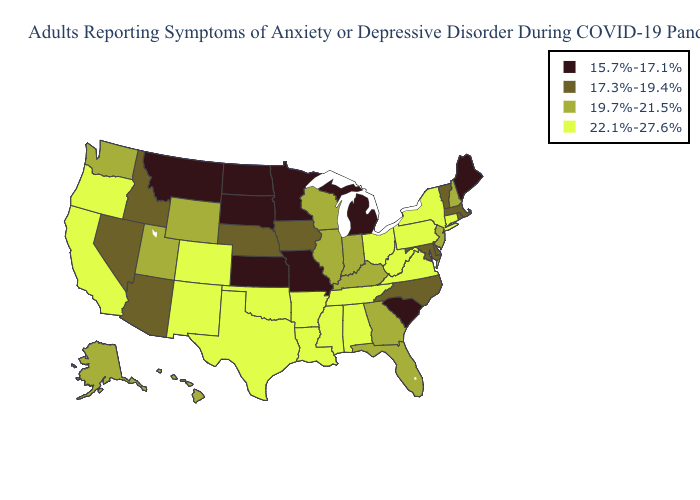What is the value of Montana?
Be succinct. 15.7%-17.1%. What is the value of Idaho?
Short answer required. 17.3%-19.4%. Among the states that border Indiana , does Ohio have the highest value?
Quick response, please. Yes. What is the highest value in the USA?
Answer briefly. 22.1%-27.6%. Which states have the highest value in the USA?
Write a very short answer. Alabama, Arkansas, California, Colorado, Connecticut, Louisiana, Mississippi, New Mexico, New York, Ohio, Oklahoma, Oregon, Pennsylvania, Tennessee, Texas, Virginia, West Virginia. Does Wyoming have the highest value in the West?
Write a very short answer. No. What is the value of Tennessee?
Concise answer only. 22.1%-27.6%. Which states have the highest value in the USA?
Give a very brief answer. Alabama, Arkansas, California, Colorado, Connecticut, Louisiana, Mississippi, New Mexico, New York, Ohio, Oklahoma, Oregon, Pennsylvania, Tennessee, Texas, Virginia, West Virginia. Does South Carolina have a lower value than Indiana?
Quick response, please. Yes. Does New York have the same value as New Mexico?
Write a very short answer. Yes. Does Wisconsin have the lowest value in the USA?
Give a very brief answer. No. Name the states that have a value in the range 17.3%-19.4%?
Concise answer only. Arizona, Delaware, Idaho, Iowa, Maryland, Massachusetts, Nebraska, Nevada, North Carolina, Rhode Island, Vermont. Name the states that have a value in the range 22.1%-27.6%?
Answer briefly. Alabama, Arkansas, California, Colorado, Connecticut, Louisiana, Mississippi, New Mexico, New York, Ohio, Oklahoma, Oregon, Pennsylvania, Tennessee, Texas, Virginia, West Virginia. Does the first symbol in the legend represent the smallest category?
Concise answer only. Yes. 